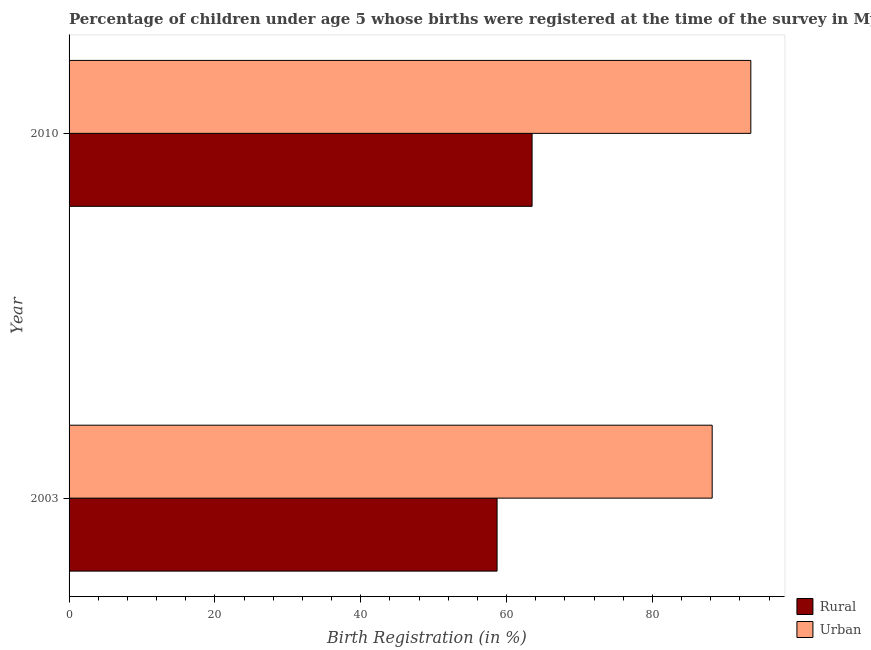Are the number of bars per tick equal to the number of legend labels?
Provide a succinct answer. Yes. Are the number of bars on each tick of the Y-axis equal?
Ensure brevity in your answer.  Yes. How many bars are there on the 1st tick from the bottom?
Make the answer very short. 2. In how many cases, is the number of bars for a given year not equal to the number of legend labels?
Offer a terse response. 0. What is the urban birth registration in 2010?
Keep it short and to the point. 93.5. Across all years, what is the maximum rural birth registration?
Provide a short and direct response. 63.5. Across all years, what is the minimum urban birth registration?
Your response must be concise. 88.2. In which year was the urban birth registration maximum?
Give a very brief answer. 2010. What is the total rural birth registration in the graph?
Your answer should be very brief. 122.2. What is the difference between the urban birth registration in 2003 and that in 2010?
Make the answer very short. -5.3. What is the difference between the urban birth registration in 2010 and the rural birth registration in 2003?
Your answer should be very brief. 34.8. What is the average rural birth registration per year?
Give a very brief answer. 61.1. In the year 2003, what is the difference between the rural birth registration and urban birth registration?
Make the answer very short. -29.5. What is the ratio of the urban birth registration in 2003 to that in 2010?
Your response must be concise. 0.94. Is the rural birth registration in 2003 less than that in 2010?
Offer a very short reply. Yes. In how many years, is the rural birth registration greater than the average rural birth registration taken over all years?
Your answer should be compact. 1. What does the 2nd bar from the top in 2003 represents?
Give a very brief answer. Rural. What does the 2nd bar from the bottom in 2010 represents?
Keep it short and to the point. Urban. How many bars are there?
Keep it short and to the point. 4. Are all the bars in the graph horizontal?
Your answer should be very brief. Yes. How many years are there in the graph?
Offer a terse response. 2. Does the graph contain grids?
Offer a terse response. No. Where does the legend appear in the graph?
Provide a short and direct response. Bottom right. How are the legend labels stacked?
Give a very brief answer. Vertical. What is the title of the graph?
Your answer should be very brief. Percentage of children under age 5 whose births were registered at the time of the survey in Myanmar. Does "Excluding technical cooperation" appear as one of the legend labels in the graph?
Keep it short and to the point. No. What is the label or title of the X-axis?
Your response must be concise. Birth Registration (in %). What is the Birth Registration (in %) of Rural in 2003?
Offer a very short reply. 58.7. What is the Birth Registration (in %) of Urban in 2003?
Provide a succinct answer. 88.2. What is the Birth Registration (in %) of Rural in 2010?
Provide a succinct answer. 63.5. What is the Birth Registration (in %) in Urban in 2010?
Give a very brief answer. 93.5. Across all years, what is the maximum Birth Registration (in %) in Rural?
Keep it short and to the point. 63.5. Across all years, what is the maximum Birth Registration (in %) of Urban?
Keep it short and to the point. 93.5. Across all years, what is the minimum Birth Registration (in %) in Rural?
Offer a terse response. 58.7. Across all years, what is the minimum Birth Registration (in %) of Urban?
Offer a very short reply. 88.2. What is the total Birth Registration (in %) of Rural in the graph?
Keep it short and to the point. 122.2. What is the total Birth Registration (in %) in Urban in the graph?
Provide a succinct answer. 181.7. What is the difference between the Birth Registration (in %) in Rural in 2003 and that in 2010?
Give a very brief answer. -4.8. What is the difference between the Birth Registration (in %) in Rural in 2003 and the Birth Registration (in %) in Urban in 2010?
Offer a very short reply. -34.8. What is the average Birth Registration (in %) of Rural per year?
Make the answer very short. 61.1. What is the average Birth Registration (in %) of Urban per year?
Give a very brief answer. 90.85. In the year 2003, what is the difference between the Birth Registration (in %) in Rural and Birth Registration (in %) in Urban?
Offer a terse response. -29.5. What is the ratio of the Birth Registration (in %) in Rural in 2003 to that in 2010?
Provide a short and direct response. 0.92. What is the ratio of the Birth Registration (in %) of Urban in 2003 to that in 2010?
Provide a succinct answer. 0.94. What is the difference between the highest and the second highest Birth Registration (in %) of Rural?
Make the answer very short. 4.8. What is the difference between the highest and the second highest Birth Registration (in %) of Urban?
Your answer should be compact. 5.3. What is the difference between the highest and the lowest Birth Registration (in %) in Rural?
Offer a terse response. 4.8. 